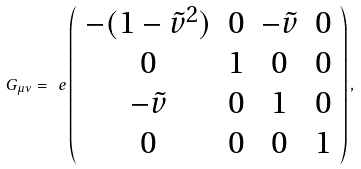Convert formula to latex. <formula><loc_0><loc_0><loc_500><loc_500>G _ { \mu \nu } = \ e \left ( \begin{array} { c c c c } - ( 1 - \tilde { v } ^ { 2 } ) & 0 & - \tilde { v } & 0 \\ 0 & 1 & 0 & 0 \\ - \tilde { v } & 0 & 1 & 0 \\ 0 & 0 & 0 & 1 \\ \end{array} \right ) ,</formula> 